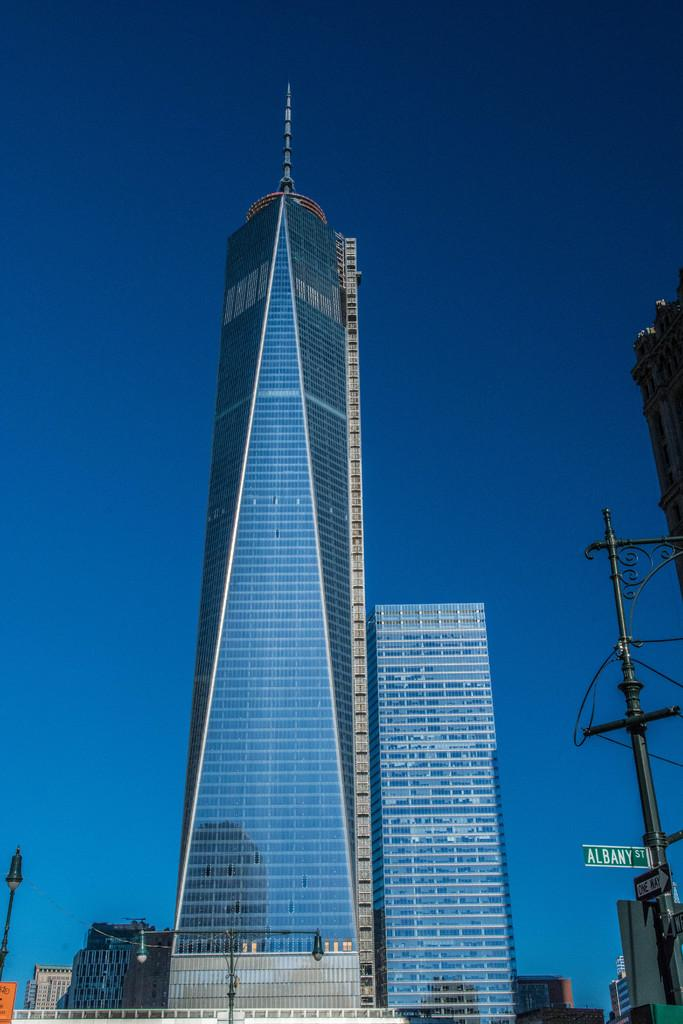What is located in the center of the image? There are buildings, poles, sign boards, and lamps in the center of the image. What type of structures can be seen in the image? There is a wall and a fence in the image. What is visible in the background of the image? The sky is visible in the background of the image. What type of hand can be seen holding a lunch in the image? There is no hand or lunch present in the image. How does the image affect the viewer's mind? The image itself does not have the ability to affect the viewer's mind; it is a static representation of the scene. 